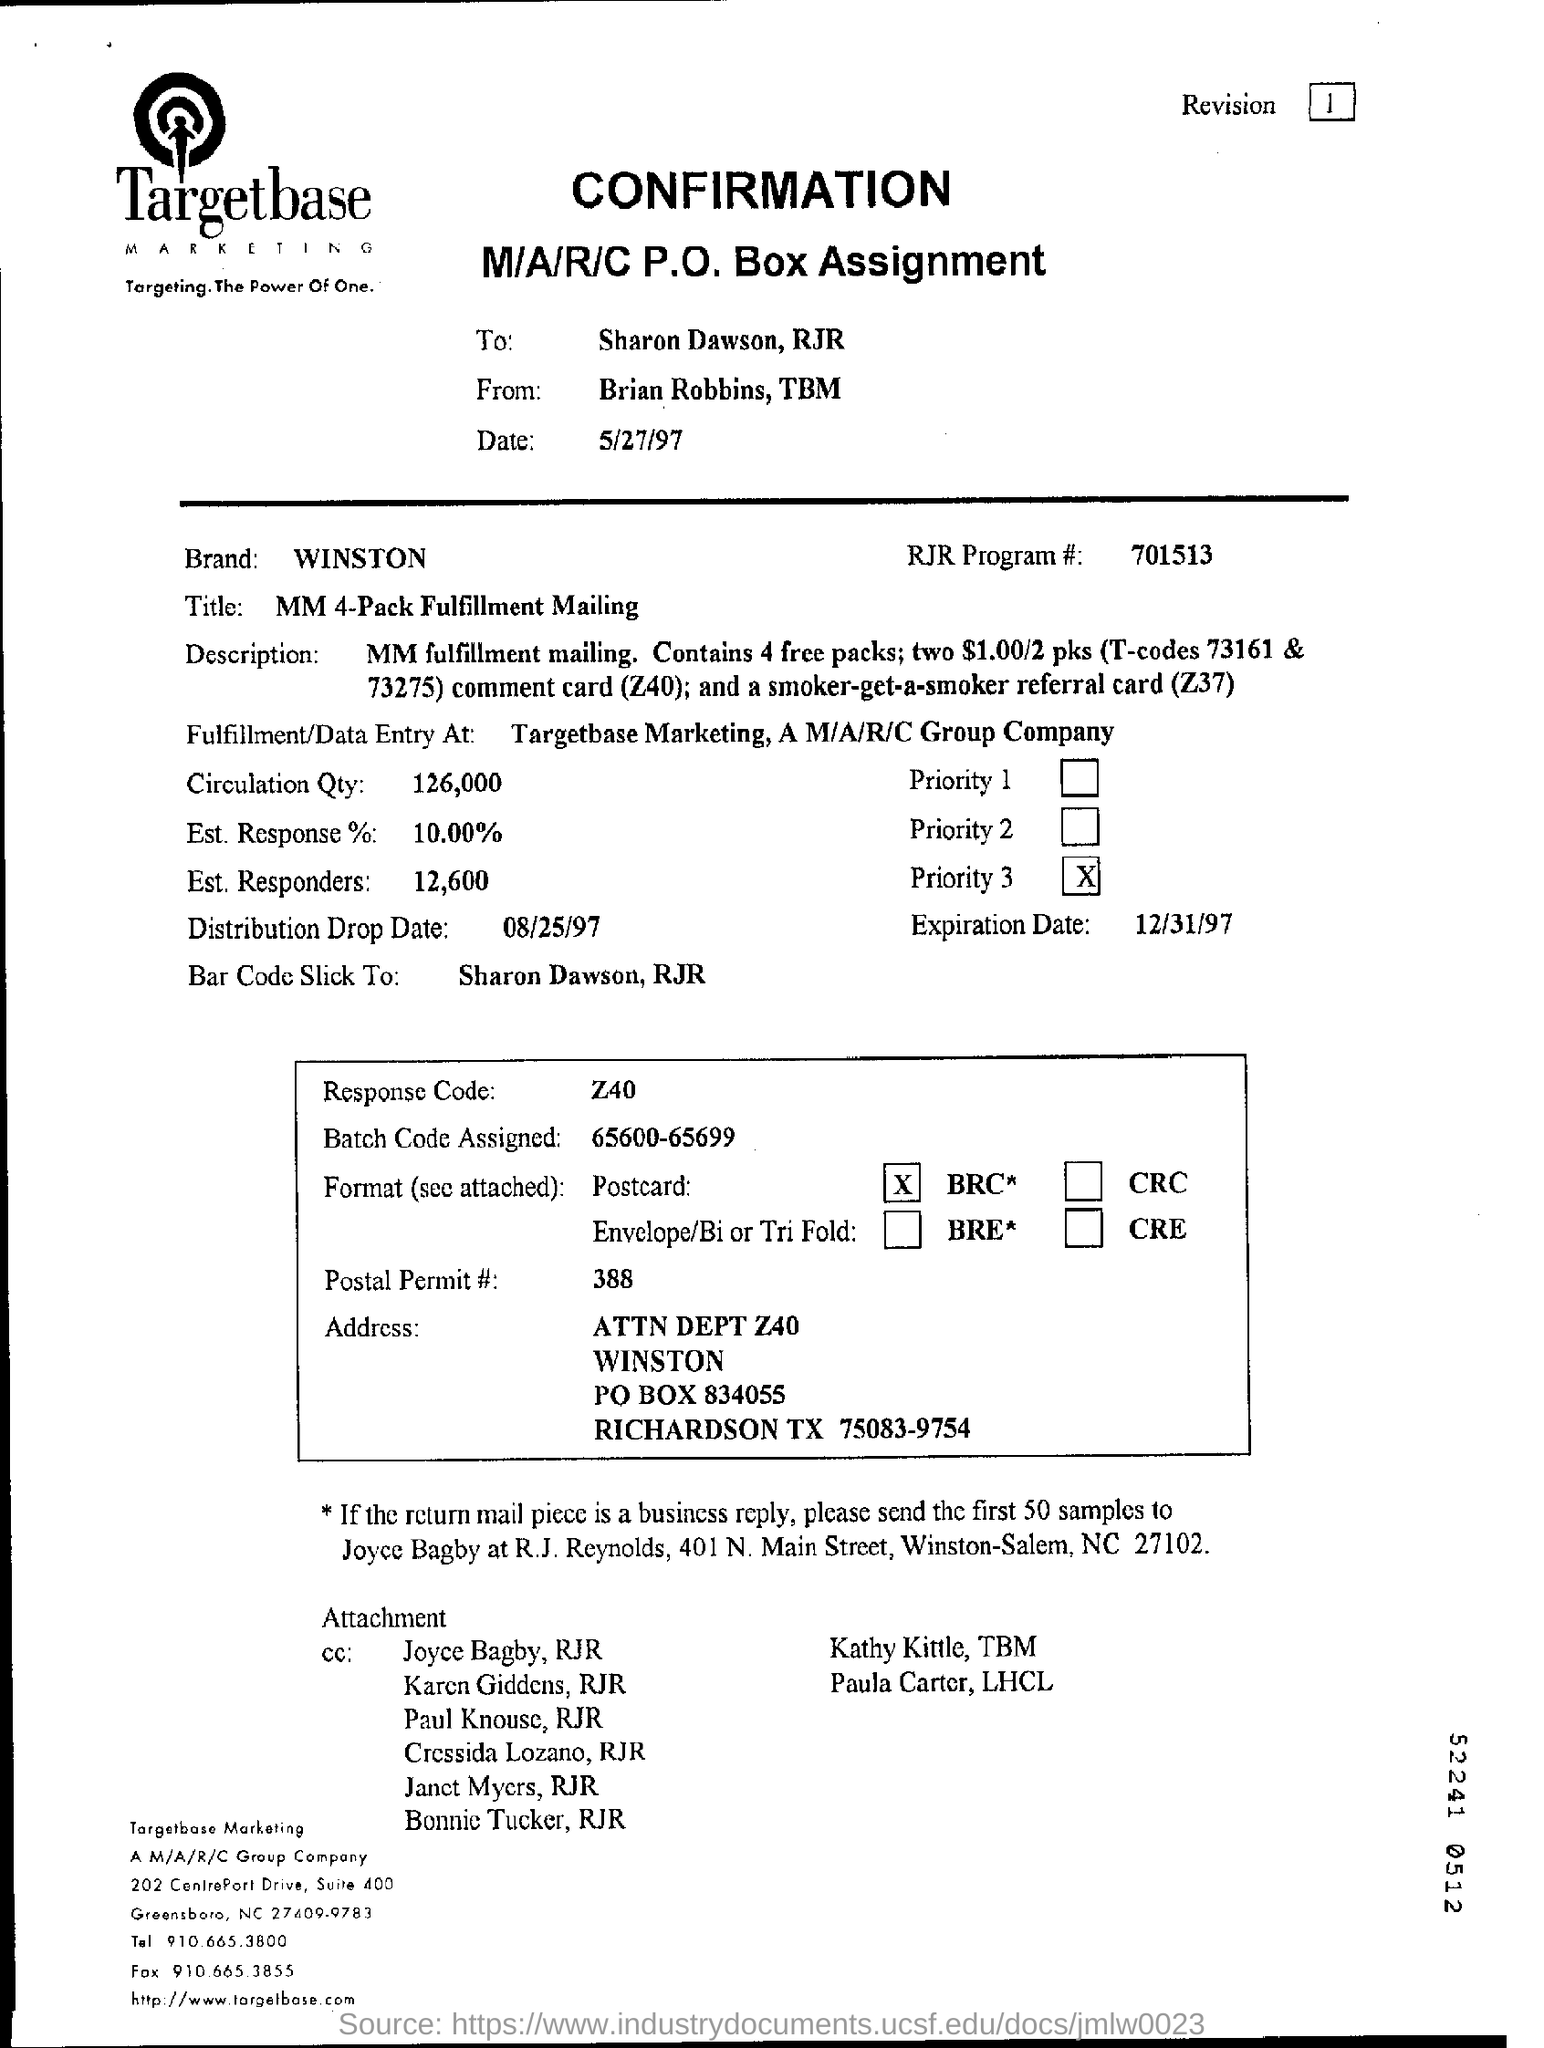Draw attention to some important aspects in this diagram. The distribution drop date is August 25, 1997. The RJR Program Number is 701513... The expiration date is December 31, 1997. The sentence "What is Response Code Number? Z40.." is asking for information about a specific type of code used in response to something. The P.O Box number is 834055. 